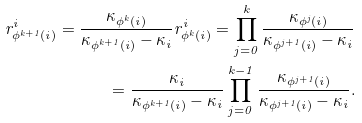<formula> <loc_0><loc_0><loc_500><loc_500>r ^ { i } _ { \phi ^ { k + 1 } ( i ) } = \frac { \kappa _ { \phi ^ { k } ( i ) } } { \kappa _ { \phi ^ { k + 1 } ( i ) } - \kappa _ { i } } r ^ { i } _ { \phi ^ { k } ( i ) } = \prod _ { j = 0 } ^ { k } \frac { \kappa _ { \phi ^ { j } ( i ) } } { \kappa _ { \phi ^ { j + 1 } ( i ) } - \kappa _ { i } } \\ = \frac { \kappa _ { i } } { \kappa _ { \phi ^ { k + 1 } ( i ) } - \kappa _ { i } } \prod _ { j = 0 } ^ { k - 1 } \frac { \kappa _ { \phi ^ { j + 1 } ( i ) } } { \kappa _ { \phi ^ { j + 1 } ( i ) } - \kappa _ { i } } .</formula> 